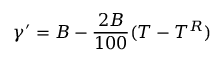Convert formula to latex. <formula><loc_0><loc_0><loc_500><loc_500>\gamma ^ { \prime } = B - { \frac { 2 B } { 1 0 0 } } ( T - T ^ { R } )</formula> 